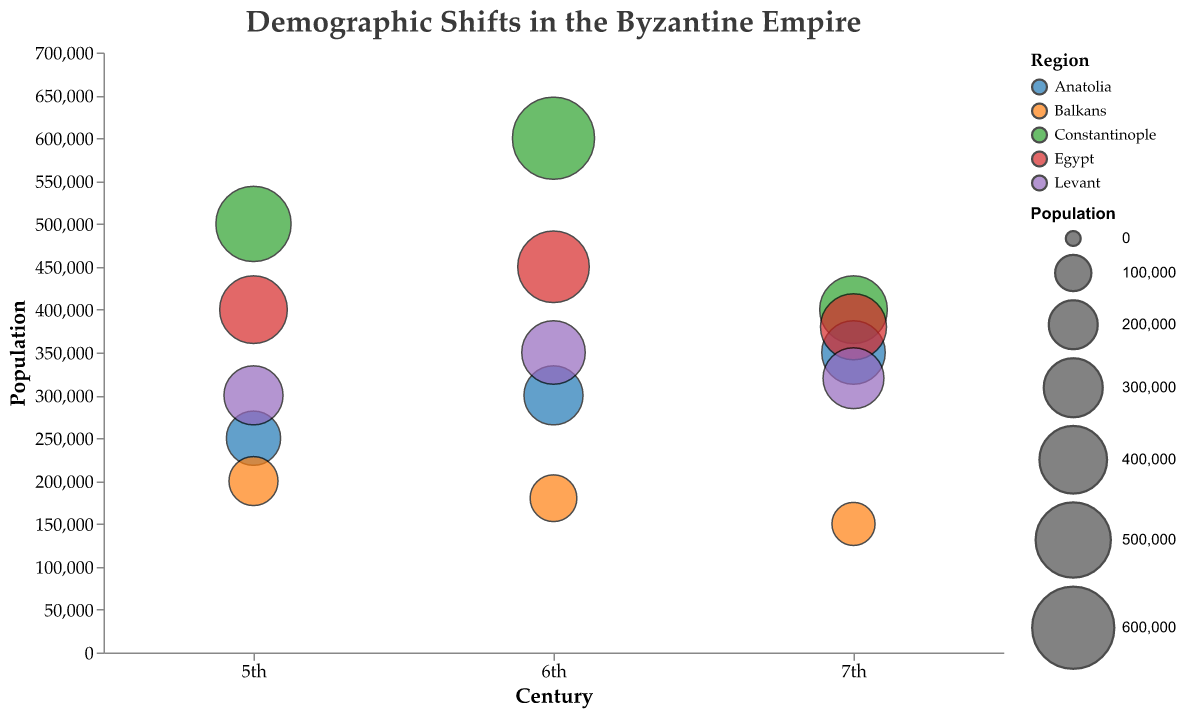What is the title of the bubble chart? The title is prominently displayed at the top of the chart. It reads "Demographic Shifts in the Byzantine Empire" in a large font size.
Answer: Demographic Shifts in the Byzantine Empire Which region had the highest population in the 6th century? By looking at the vertical position of the bubbles along the y-axis for the 6th century, the bubble for Constantinople reaches the highest population value.
Answer: Constantinople How does the population increase rate change for Constantinople from the 5th to the 7th century? In the 5th century, Constantinople had a population increase rate of 5. In the 6th century, it increased to 20, but in the 7th century, it drastically decreased to -33. This pattern shows initial growth followed by a sharp decline.
Answer: It increased initially and then sharply declined Which century showed the highest population for Egypt? Observing the bubbles for Egypt, the bubble in the 6th century is the highest, representing the highest population.
Answer: 6th century Comparing Anatolia and the Levant, which region had a higher population in the 7th century? By comparing the vertical positions of the bubbles for both regions in the 7th century, the bubble for Anatolia is higher on the y-axis than the one for the Levant.
Answer: Anatolia What is the relationship between population and increase rate for the Balkans in the 6th and 7th centuries? The bubble for the Balkans in the 6th century shows a population of 180,000 with an increase rate of -10, and in the 7th century, it shows a population of 150,000 with an increase rate of -17. The decrease in the population is accompanied by a worsening (more negative) increase rate.
Answer: Decreasing population with worsening increase rate Identify a region that continually grew in population from the 5th to the 7th century. Examining the trend of the bubbles over the centuries, Anatolia shows a continuous increase in population from 250,000 in the 5th century to 350,000 in the 7th century.
Answer: Anatolia Which region experienced the sharpest negative population growth in the 7th century? The bubble for Constantinople in the 7th century has the sharpest negative population growth with an increase rate of -33.
Answer: Constantinople Which regions had a negative population increase rate in the 6th and 7th centuries? By looking at the tooltip data for bubbles in the 6th and 7th centuries, the Balkans had a negative increase rate in both the 6th (-10) and 7th (-17) centuries.
Answer: Balkans How does the population size visually compare between the 5th and 6th centuries for the Levant region? The bubble for the Levant in the 6th century is larger and higher on the y-axis compared to the bubble in the 5th century, indicating an increase in population.
Answer: Larger and higher in the 6th century 